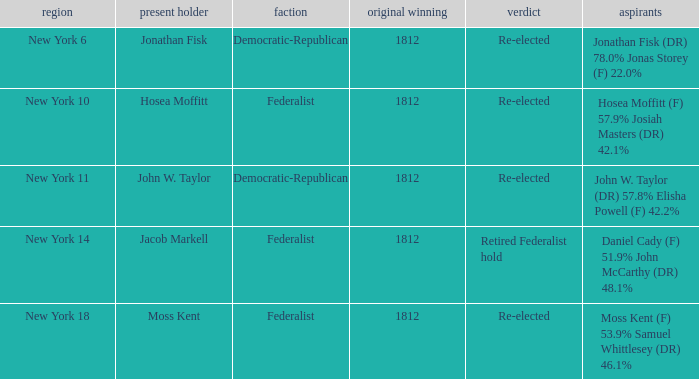Name the first elected for jacob markell 1812.0. 